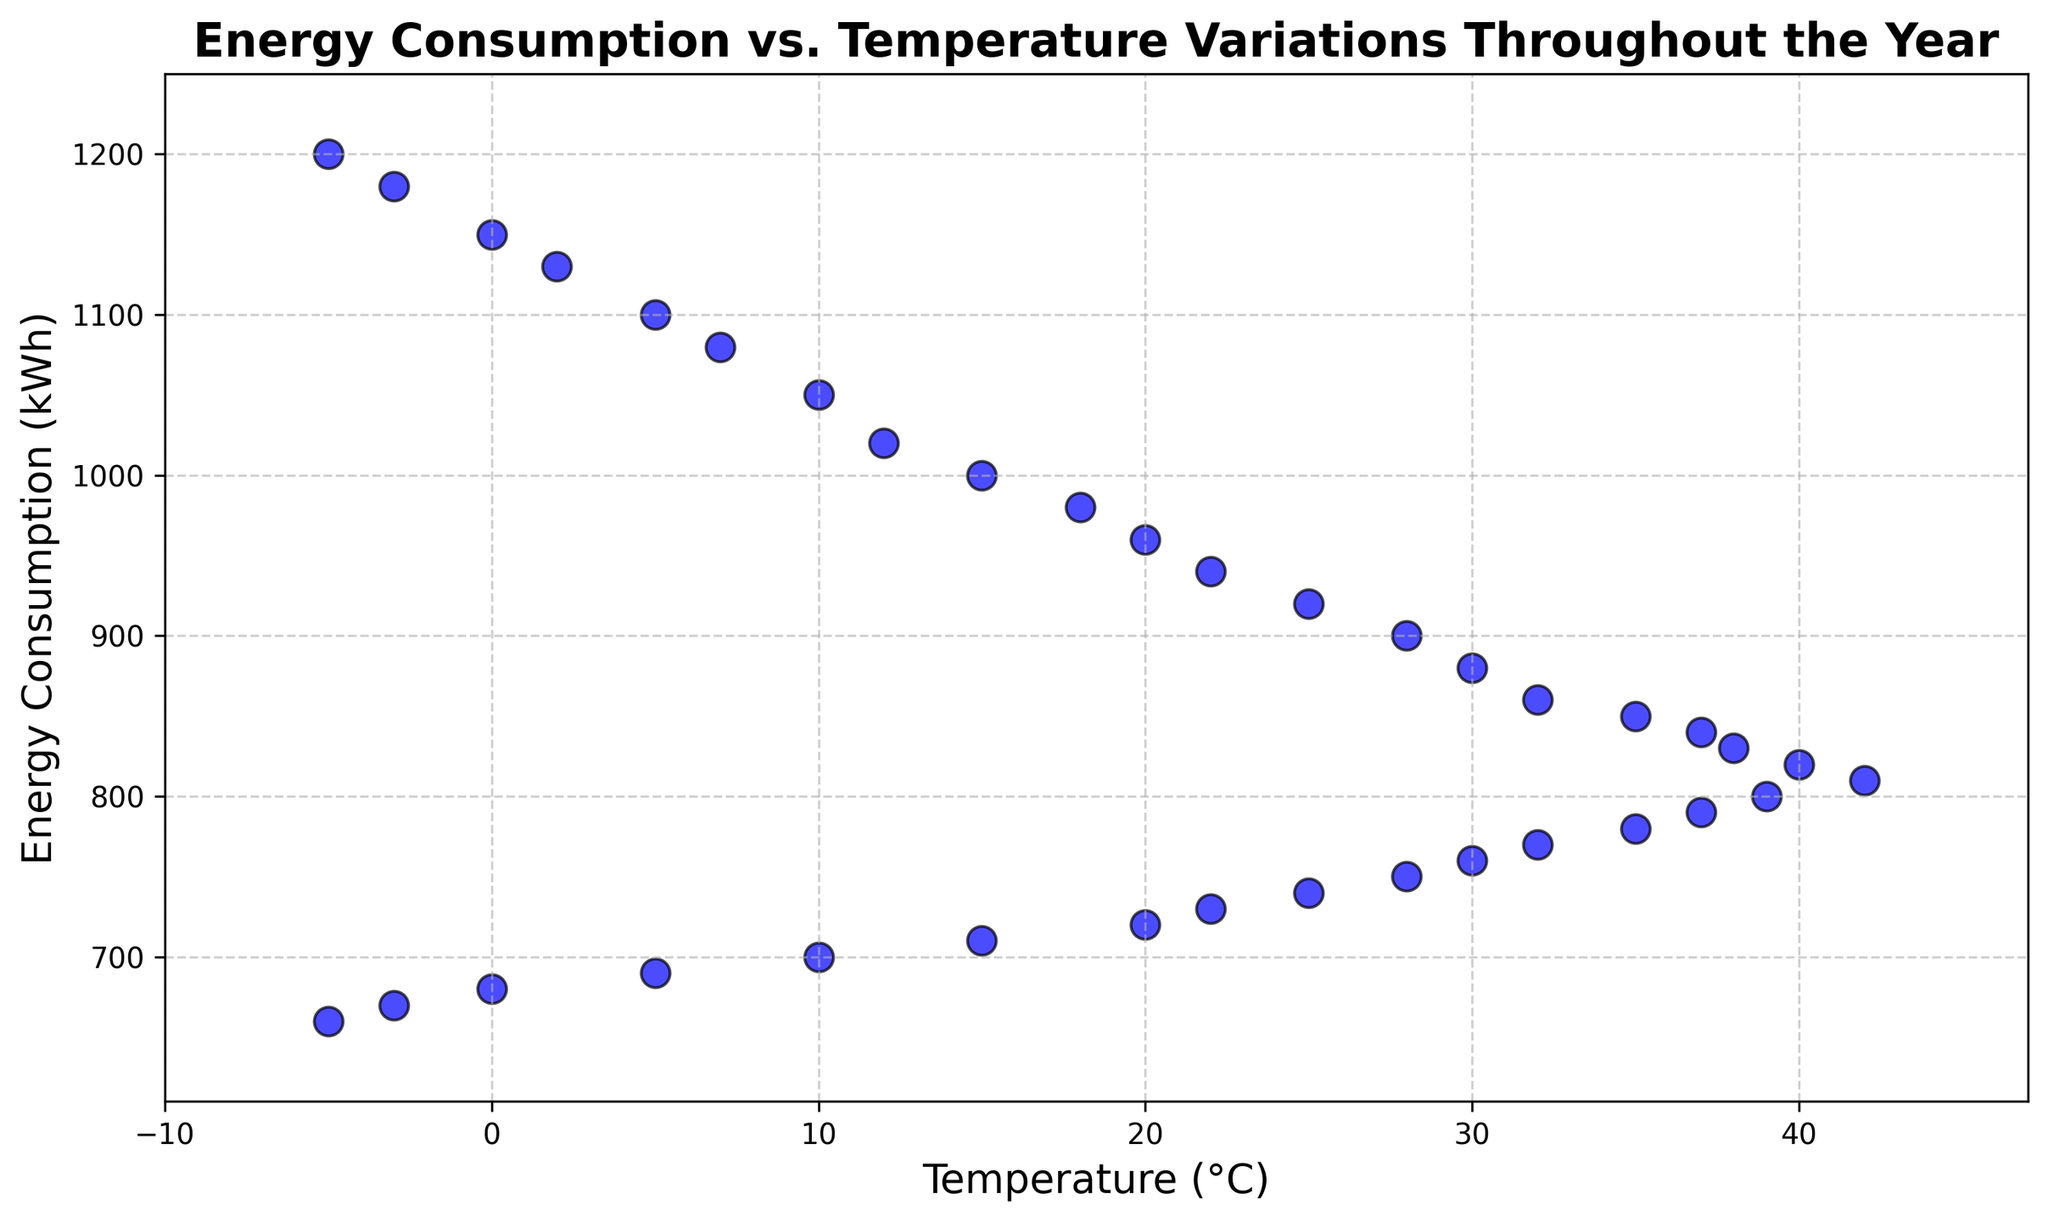What's the general relationship between temperature and energy consumption? As the temperature increases, energy consumption generally decreases. This can be seen by observing the scatter plot, where higher temperatures correspond to lower energy consumption values.
Answer: Energy consumption decreases with increasing temperature At what temperature is energy consumption the lowest? The scatter plot shows that the lowest energy consumption (660 kWh) occurs at a temperature of -5°C.
Answer: -5°C Is there a point where energy consumption is higher than 1150 kWh? By glancing through the chart, it's clear that no plotted point shows energy consumption higher than 1150 kWh.
Answer: No What's the difference in energy consumption between the coldest and hottest days? The coldest temperature is -5°C with 1200 kWh and the hottest is 42°C with 810 kWh. The difference is 1200 - 810 = 390 kWh.
Answer: 390 kWh Which month shows the lowest overall energy consumption trend? By examining clusters of points along the x-axis, August shows the lowest trend in energy consumption since the points are around 800 kWh.
Answer: August What is the average energy consumption for temperatures above 30°C? For temperatures above 30°C (32, 35, 37, 38, 40, 42, 39, 37, 35), the energy consumption values are (860, 850, 840, 830, 820, 810, 800, 790, 780). The sum is 7480, and there are 9 data points, so the average is 7480 / 9 ≈ 831 kWh.
Answer: 831 kWh What is the energy consumption range for temperatures between 0°C and 10°C? In the specified temperature range, the energy consumptions are 1150 kWh, 1130 kWh, and 1100 kWh. The range is 1150 - 1100 = 50 kWh.
Answer: 50 kWh Which season shows the highest energy consumption during the respective temperature ranges? Observing the scatter plot:
- Winter (December to February): around 1200 kWh
- Spring (March to May): around 1000 kWh
- Summer (June to August): around 820 kWh
- Autumn (September to November): around 730 kWh
Winter has the highest energy consumption.
Answer: Winter Is there a temperature where energy consumption is below 700 kWh? From the scatter plot, it's seen that the energy consumption for December (0°C, -3°C, -5°C) shows readings of 680 kWh, 670 kWh, 660 kWh respectively, all below 700 kWh.
Answer: Yes What can be inferred about energy consumption patterns from the scatter plot? The scatter plot indicates that energy consumption generally decreases as the temperature increases. The highest consumption occurs during colder temperatures, likely due to heating needs, while the lowest consumption occurs during higher temperatures, possibly due to reduced heating and optimized cooling systems.
Answer: Decreases with rising temperature 